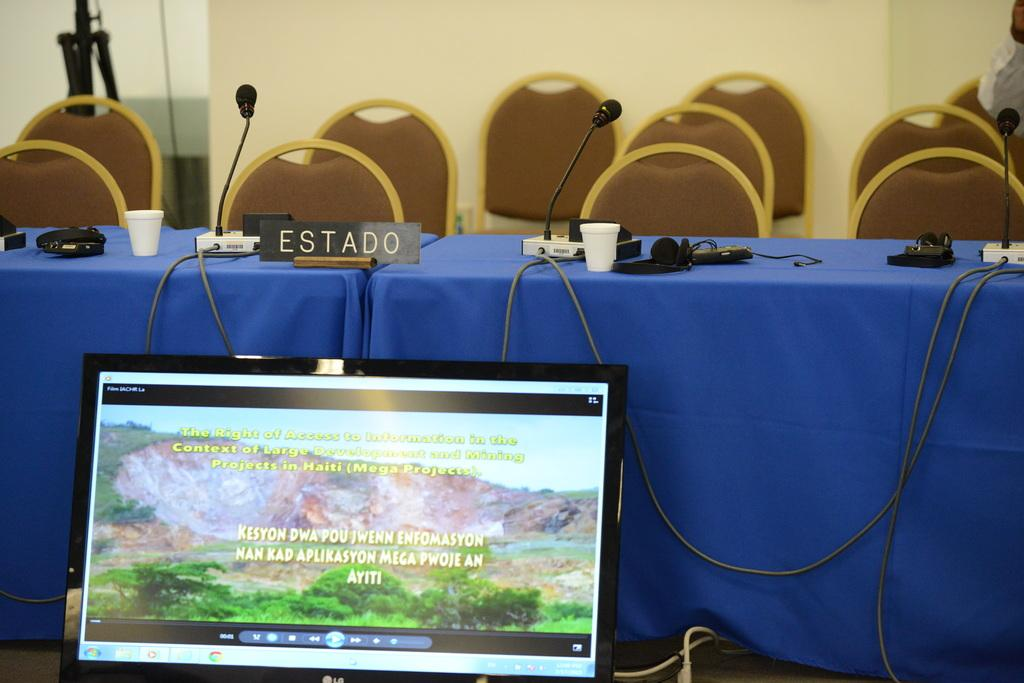<image>
Write a terse but informative summary of the picture. the name Kesyon is on the computer screen 